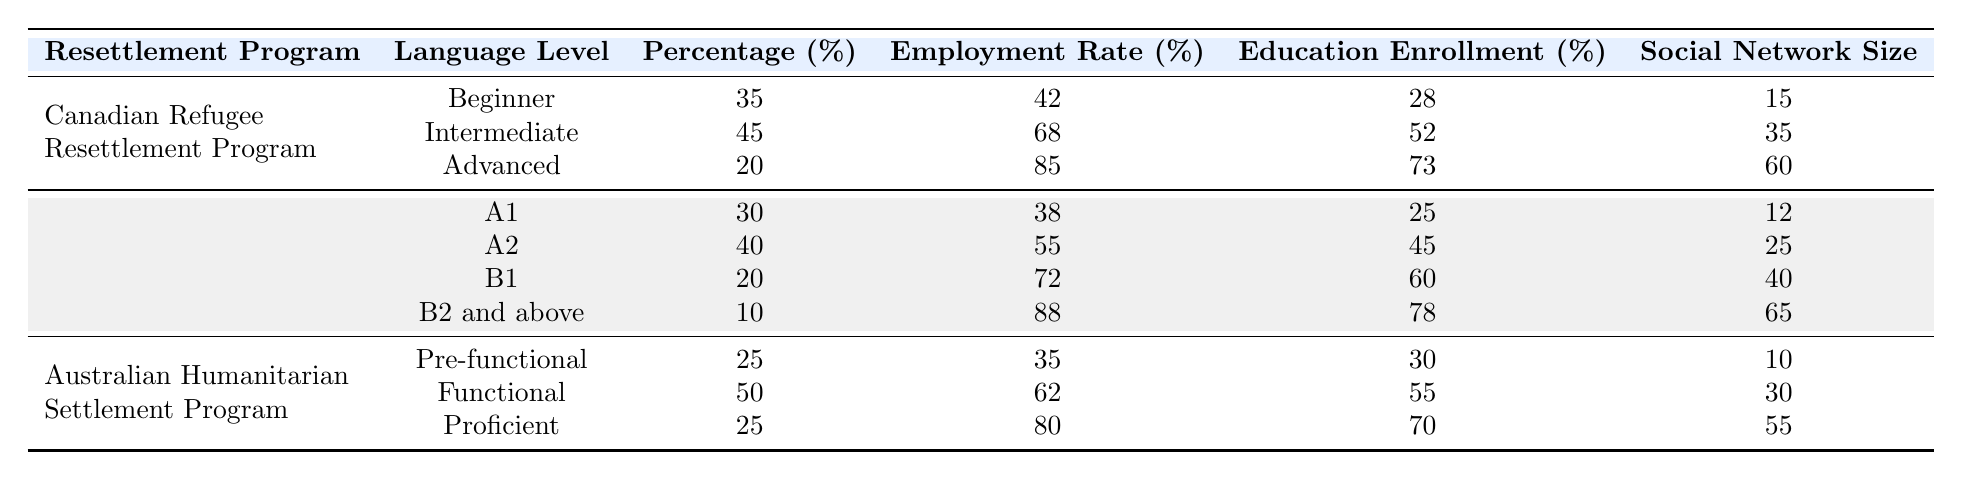What is the employment rate for refugees at the Advanced language proficiency level in the Canadian Refugee Resettlement Program? The table shows that for the Advanced level, the employment rate is listed as 85%.
Answer: 85% What percentage of refugees are at the Intermediate language proficiency level in the Canadian Refugee Resettlement Program? According to the table, the percentage of refugees at the Intermediate level is 45%.
Answer: 45% Which resettlement program has the highest employment rate for the Proficient language level? In the table, the Australian Humanitarian Settlement Program shows an employment rate of 80% for the Proficient level, while the other programs do not have a Proficient category, so it's the highest for that level.
Answer: Australian Humanitarian Settlement Program What is the average education enrollment rate for all language proficiency levels within the German Integration Program? Adding the education enrollment rates for all levels (25 + 45 + 60 + 78) gives a total of 208. Dividing by the number of levels (4) results in an average of 52%.
Answer: 52% Is the social network size for Intermediate level refugees in the Canadian Refugee Resettlement Program higher than that for A1 level refugees in the German Integration Program? The social network size for the Intermediate level is 35, while for A1, it is 12. Since 35 is greater than 12, the statement is true.
Answer: Yes How does the employment rate of refugees with Functional language proficiency in the Australian Humanitarian Settlement Program compare to that of refugees with the B2 and above level in the German Integration Program? The table indicates the employment rate for the Functional level is 62%, while for B2 and above, it is 88%. Since 62 is less than 88, the Functional level has a lower employment rate.
Answer: Lower What percentage of refugees are in the Beginner category under the Canadian Refugee Resettlement Program compared to the Pre-functional category under the Australian Humanitarian Settlement Program? The Beginner category has a percentage of 35% and the Pre-functional category has 25%. To compare, Beginner (35) is greater than Pre-functional (25).
Answer: Beginner is higher Which language level across all programs has the largest proportion of refugees and what is that percentage? Looking through the table, the Intermediate level in the Canadian Refugee Resettlement Program has the highest percentage at 45%.
Answer: Intermediate at 45% How many refugees are included in the German Integration Program at the B1 level if the total number of resettled refugees is known to be 1000? The percentage for the B1 level is 20%. Therefore, 20% of 1000 results in 200 refugees at the B1 level.
Answer: 200 What is the difference in social network size between Advanced level refugees in the Canadian Refugee Resettlement Program and B1 level refugees in the German Integration Program? The social network size for Advanced level is 60 and for B1 level is 40. The difference is 60 - 40 = 20.
Answer: 20 